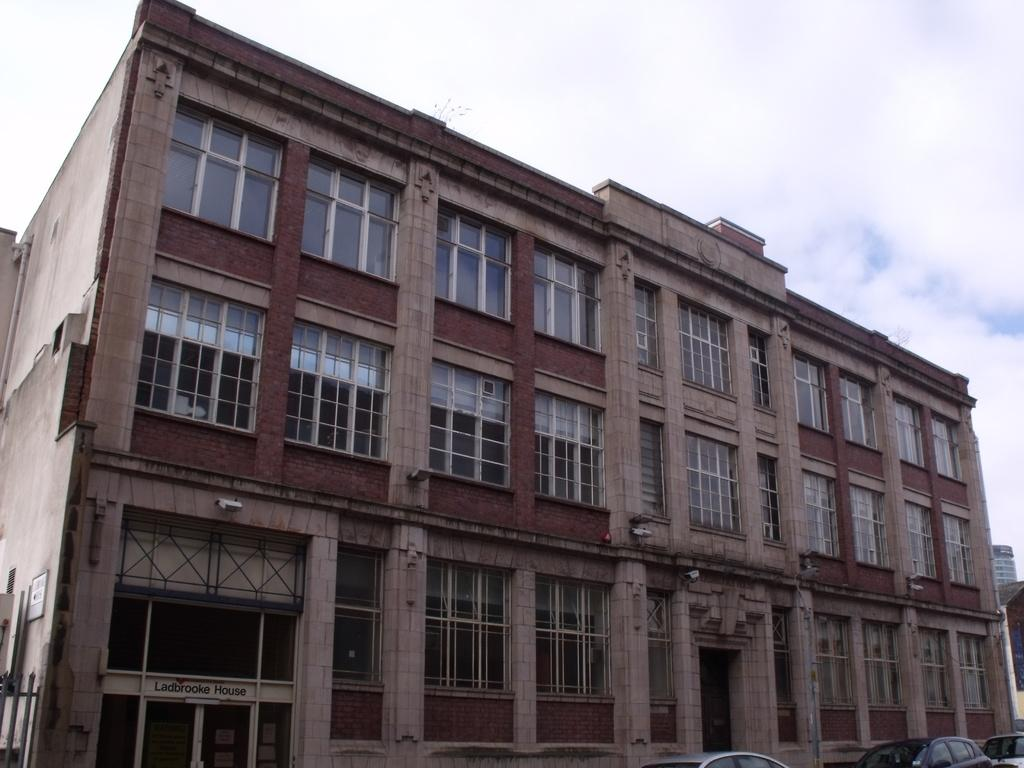What type of structure is visible in the image? There is a building in the image. What feature can be seen on the building? The building has a window. What else is present near the building? There are parked cars near the building. What can be seen in the background of the image? The sky is visible in the background of the image. What is the condition of the sky in the image? Clouds are present in the sky. What type of bike can be seen leaning against the building in the image? There is no bike present in the image; it only features a building, parked cars, and clouds in the sky. What acoustics can be heard coming from the building in the image? There is no information about any sounds or acoustics in the image, as it only shows a building, parked cars, and clouds in the sky. 